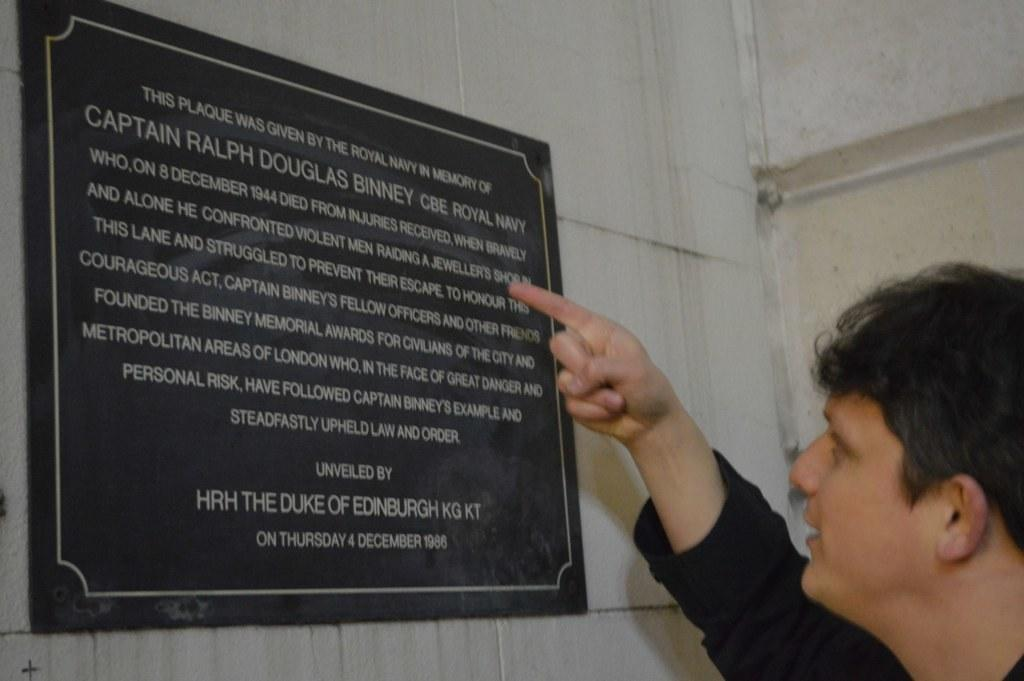What is the man in the image wearing? The man in the image is wearing a black t-shirt. What can be seen on the wall in the image? There is a board on the wall in the image. What is written or displayed on the board? There is text on the board in the image. What type of sack is being used to carry the man in the image? There is no sack present in the image, and the man is not being carried. 